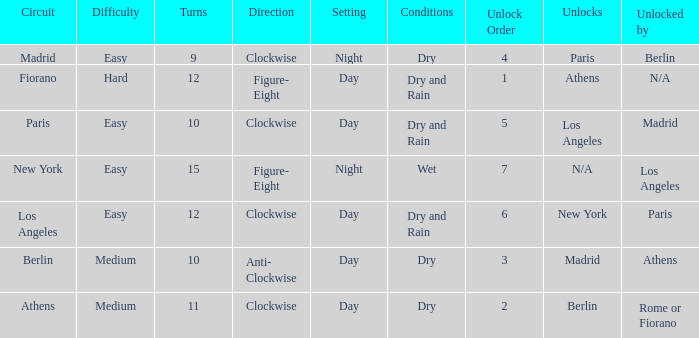What is the difficulty of the athens circuit? Medium. 